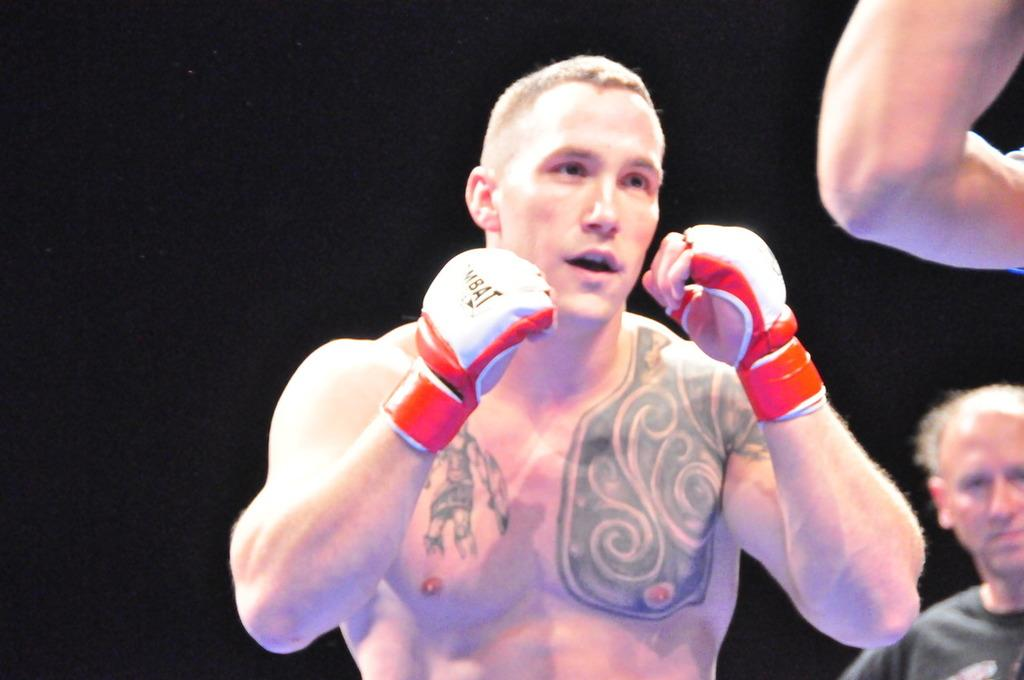What is happening in the image? There are people standing in the image, and a man appears to be preparing for boxing. Can you describe the man's attire? The man is wearing gloves on his hands. What can be observed about the background of the image? The background of the image is dark. Can you see any clover growing in the image? There is no clover present in the image; it features people standing and a man preparing for boxing. What type of needle is the man using to sew his gloves in the image? There is no needle present in the image, as the man is wearing gloves for boxing, not sewing. 